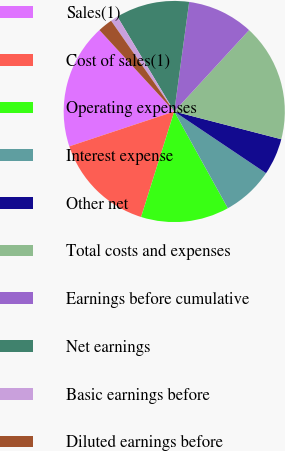Convert chart to OTSL. <chart><loc_0><loc_0><loc_500><loc_500><pie_chart><fcel>Sales(1)<fcel>Cost of sales(1)<fcel>Operating expenses<fcel>Interest expense<fcel>Other net<fcel>Total costs and expenses<fcel>Earnings before cumulative<fcel>Net earnings<fcel>Basic earnings before<fcel>Diluted earnings before<nl><fcel>18.28%<fcel>15.05%<fcel>12.9%<fcel>7.53%<fcel>5.38%<fcel>17.2%<fcel>9.68%<fcel>10.75%<fcel>1.08%<fcel>2.15%<nl></chart> 